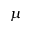Convert formula to latex. <formula><loc_0><loc_0><loc_500><loc_500>\mu</formula> 